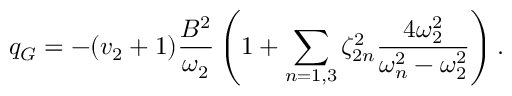Convert formula to latex. <formula><loc_0><loc_0><loc_500><loc_500>q _ { G } = - ( v _ { 2 } + 1 ) \frac { B ^ { 2 } } { \omega _ { 2 } } \left ( 1 + \sum _ { n = 1 , 3 } \zeta _ { 2 n } ^ { 2 } \frac { 4 \omega _ { 2 } ^ { 2 } } { \omega _ { n } ^ { 2 } - \omega _ { 2 } ^ { 2 } } \right ) .</formula> 